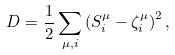<formula> <loc_0><loc_0><loc_500><loc_500>D = \frac { 1 } { 2 } \sum _ { \mu , i } \left ( S _ { i } ^ { \mu } - \zeta _ { i } ^ { \mu } \right ) ^ { 2 } ,</formula> 